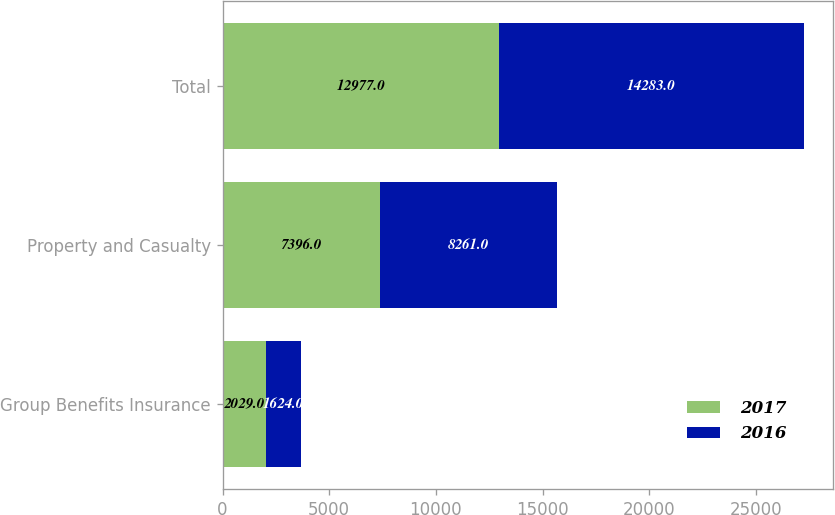Convert chart to OTSL. <chart><loc_0><loc_0><loc_500><loc_500><stacked_bar_chart><ecel><fcel>Group Benefits Insurance<fcel>Property and Casualty<fcel>Total<nl><fcel>2017<fcel>2029<fcel>7396<fcel>12977<nl><fcel>2016<fcel>1624<fcel>8261<fcel>14283<nl></chart> 